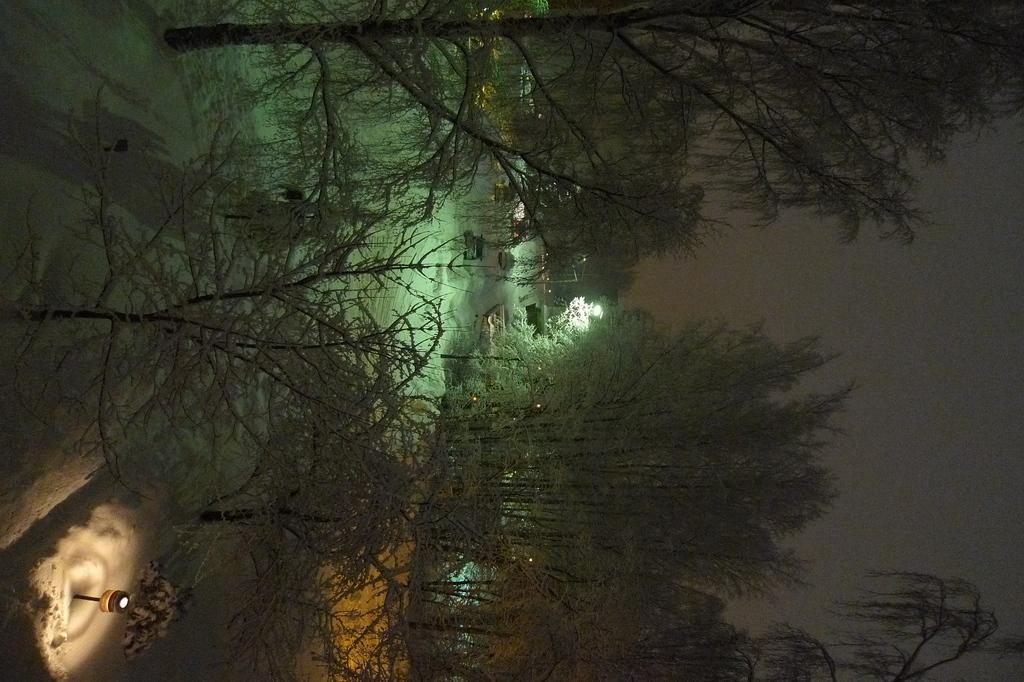What is happening on the snow in the image? There are vehicles on the snow in the image. What type of natural environment is visible in the image? There are trees visible in the image. What type of structures can be seen in the image? There are houses visible in the image. What type of instrument is being played by the trees in the image? There are no instruments present in the image, as it features vehicles on the snow, trees, and houses. 